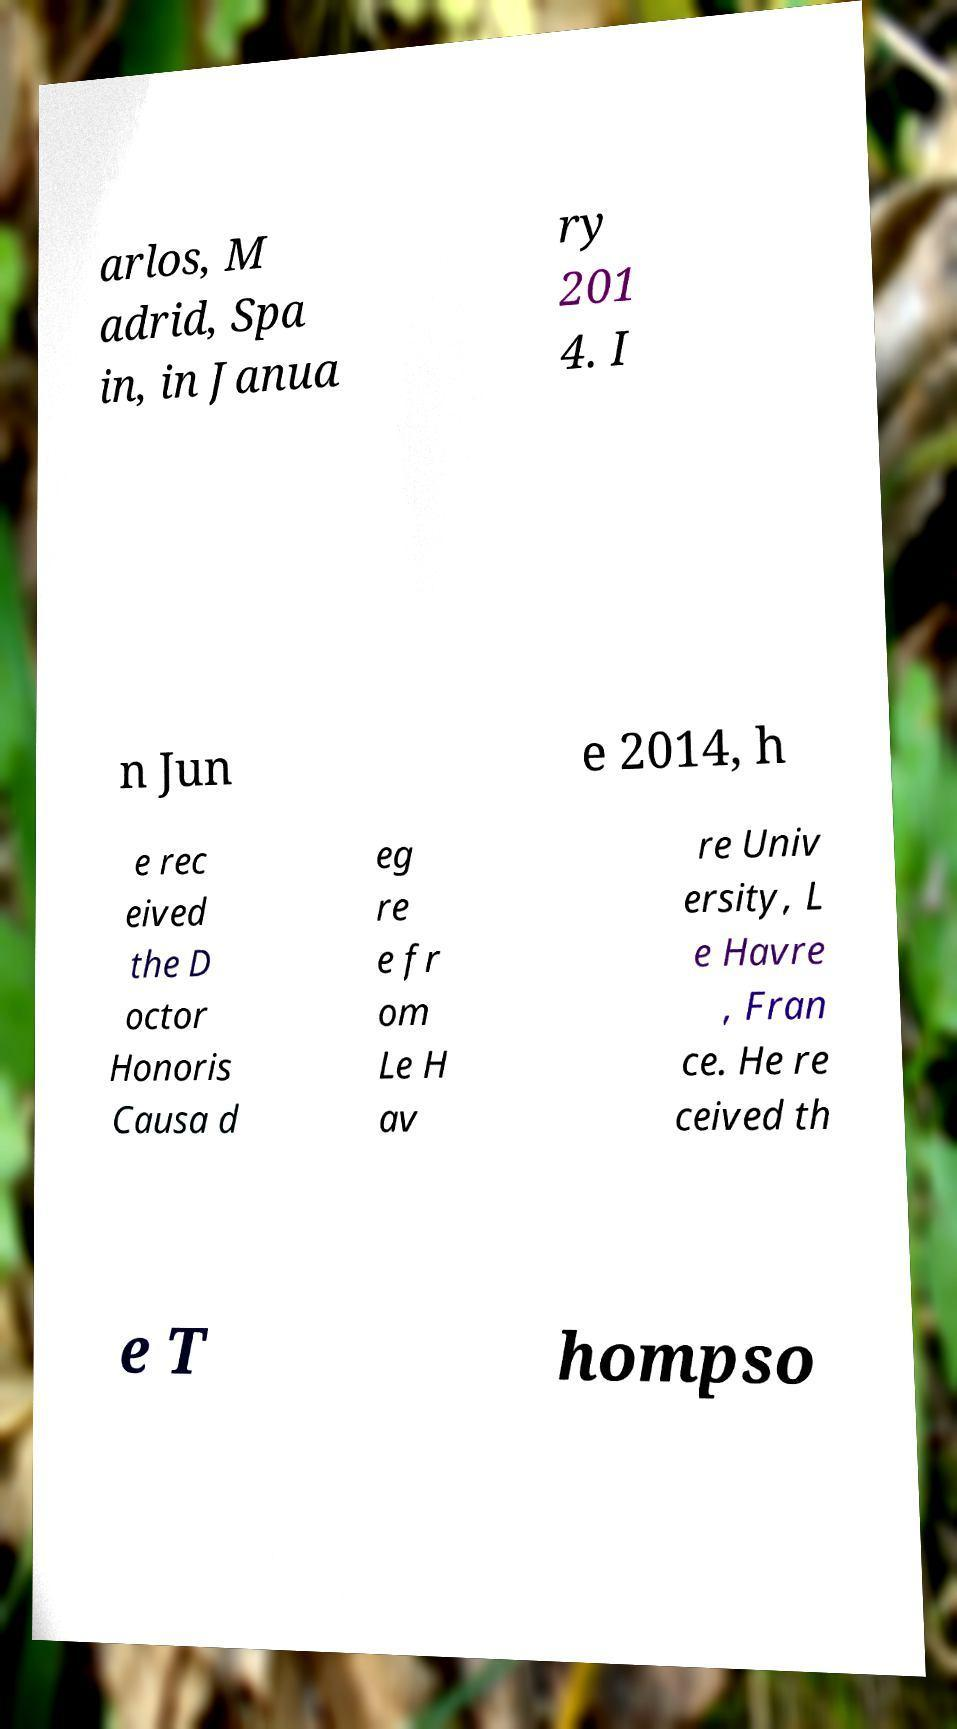Please identify and transcribe the text found in this image. arlos, M adrid, Spa in, in Janua ry 201 4. I n Jun e 2014, h e rec eived the D octor Honoris Causa d eg re e fr om Le H av re Univ ersity, L e Havre , Fran ce. He re ceived th e T hompso 